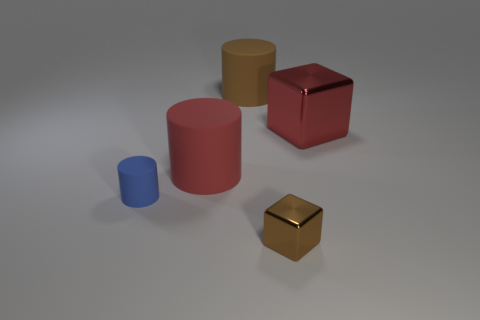Add 5 tiny red rubber balls. How many objects exist? 10 Subtract all blocks. How many objects are left? 3 Add 2 blue matte cylinders. How many blue matte cylinders are left? 3 Add 1 big red rubber cylinders. How many big red rubber cylinders exist? 2 Subtract 0 green cylinders. How many objects are left? 5 Subtract all big brown shiny cubes. Subtract all red matte objects. How many objects are left? 4 